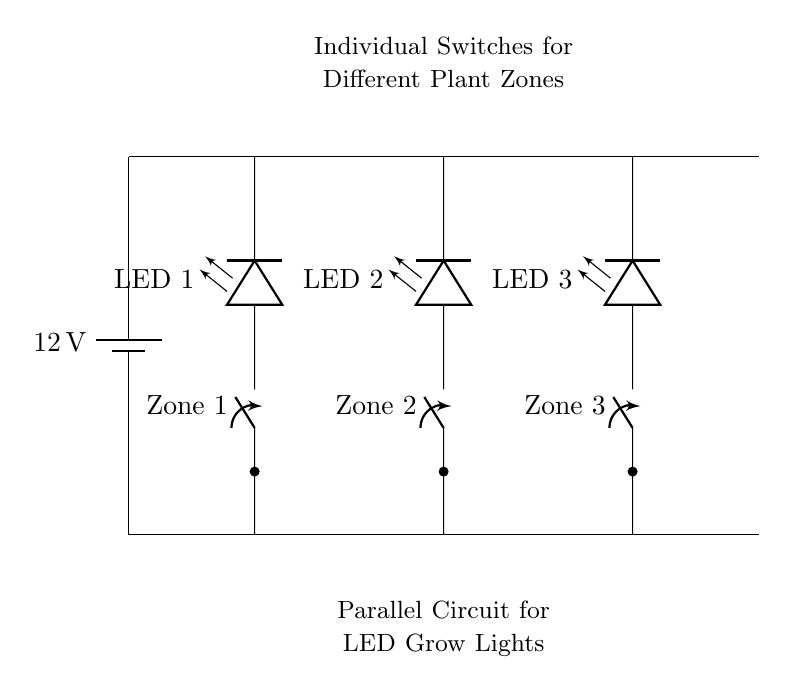What is the voltage of this circuit? The voltage is 12 volts, which can be found labeled on the battery symbol at the top left of the circuit diagram.
Answer: 12 volts How many plant zones are there in this circuit? There are three plant zones, as indicated by the three switches labeled Zone 1, Zone 2, and Zone 3.
Answer: Three What type of circuit is shown in this diagram? The circuit is a parallel circuit, as the branches with switches and LEDs are connected across the same two voltage rails.
Answer: Parallel What is the purpose of the individual switches? The individual switches allow for independent control of the LED lights in each plant zone, enabling them to be turned on or off separately.
Answer: Independent control Which component is connected to Zone 2? The component connected to Zone 2 is LED 2, indicated by the drawing that shows the wire connecting from the Zone 2 switch to LED 2.
Answer: LED 2 Are the LED lights in series or parallel with each other? The LED lights are in parallel with each other since each LED is connected to the same voltage source independently, without any other components in between.
Answer: Parallel What happens if one switch fails? If one switch fails, it will only affect the respective plant zone, and the other zones will continue to function properly due to the parallel configuration of the circuit.
Answer: Only affects one zone 